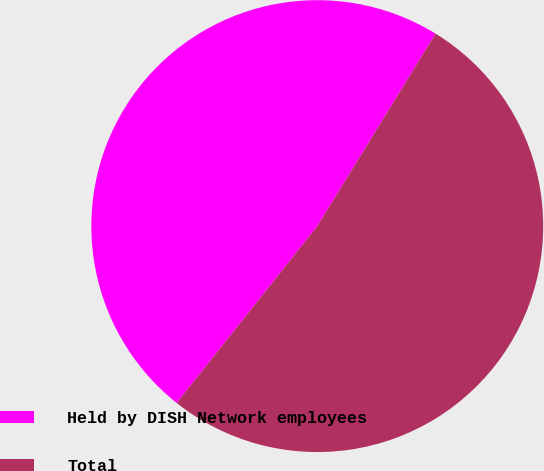Convert chart. <chart><loc_0><loc_0><loc_500><loc_500><pie_chart><fcel>Held by DISH Network employees<fcel>Total<nl><fcel>48.08%<fcel>51.92%<nl></chart> 